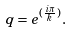Convert formula to latex. <formula><loc_0><loc_0><loc_500><loc_500>q = e ^ { ( \frac { i \pi } { k } ) } .</formula> 